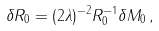Convert formula to latex. <formula><loc_0><loc_0><loc_500><loc_500>\delta R _ { 0 } = ( 2 \lambda ) ^ { - 2 } R _ { 0 } ^ { - 1 } \delta M _ { 0 } \, ,</formula> 